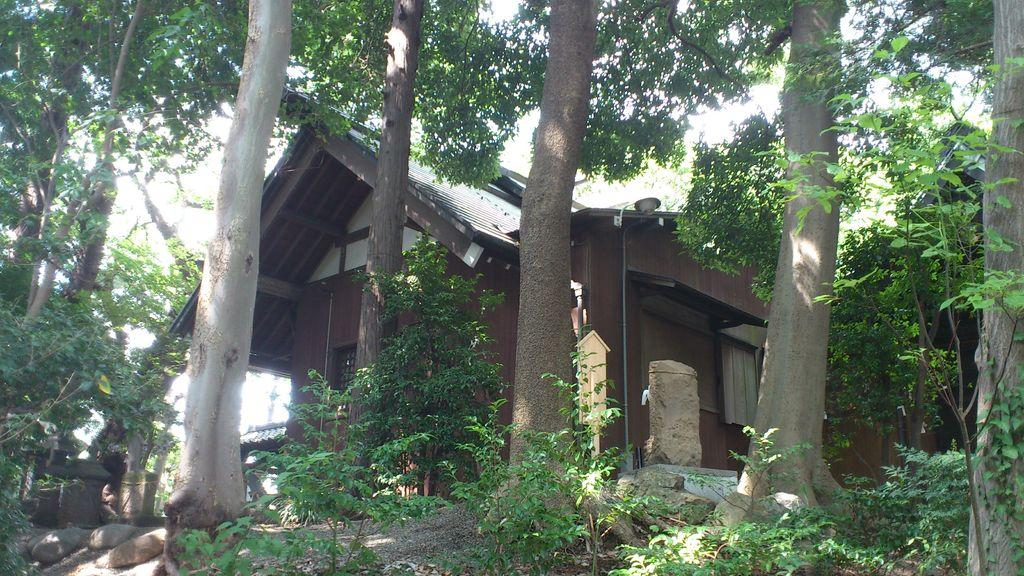What type of structure is present in the picture? There is a house in the picture. What other natural elements can be seen in the picture? There are plants, trees, and rocks in the picture. Are there any other objects present in the picture besides the house and natural elements? Yes, there are other objects in the picture. What can be seen in the background of the picture? The sky is visible in the background of the picture. What type of cake is being served at the house in the picture? There is no cake present in the image; it only shows a house, plants, trees, rocks, and other objects. Can you describe the body language of the people in the picture? There are no people present in the image, so it is not possible to describe their body language. 